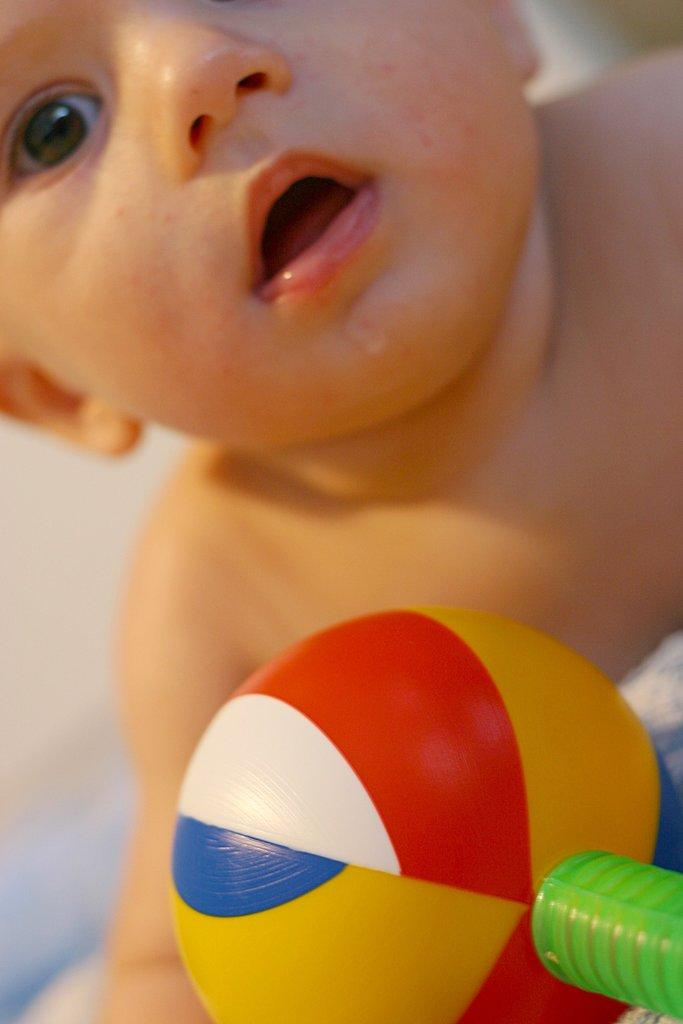What is the main subject of the image? There is a baby in the image. What other object can be seen in the image? There is a colorful plastic toy in the image. Where are the baby and the toy located in the image? Both the baby and the toy are in the center of the image. What role does the actor play in the image? There is no actor present in the image; it features a baby and a toy. What is the baby's hope for the future in the image? The image does not convey any information about the baby's hopes for the future. 